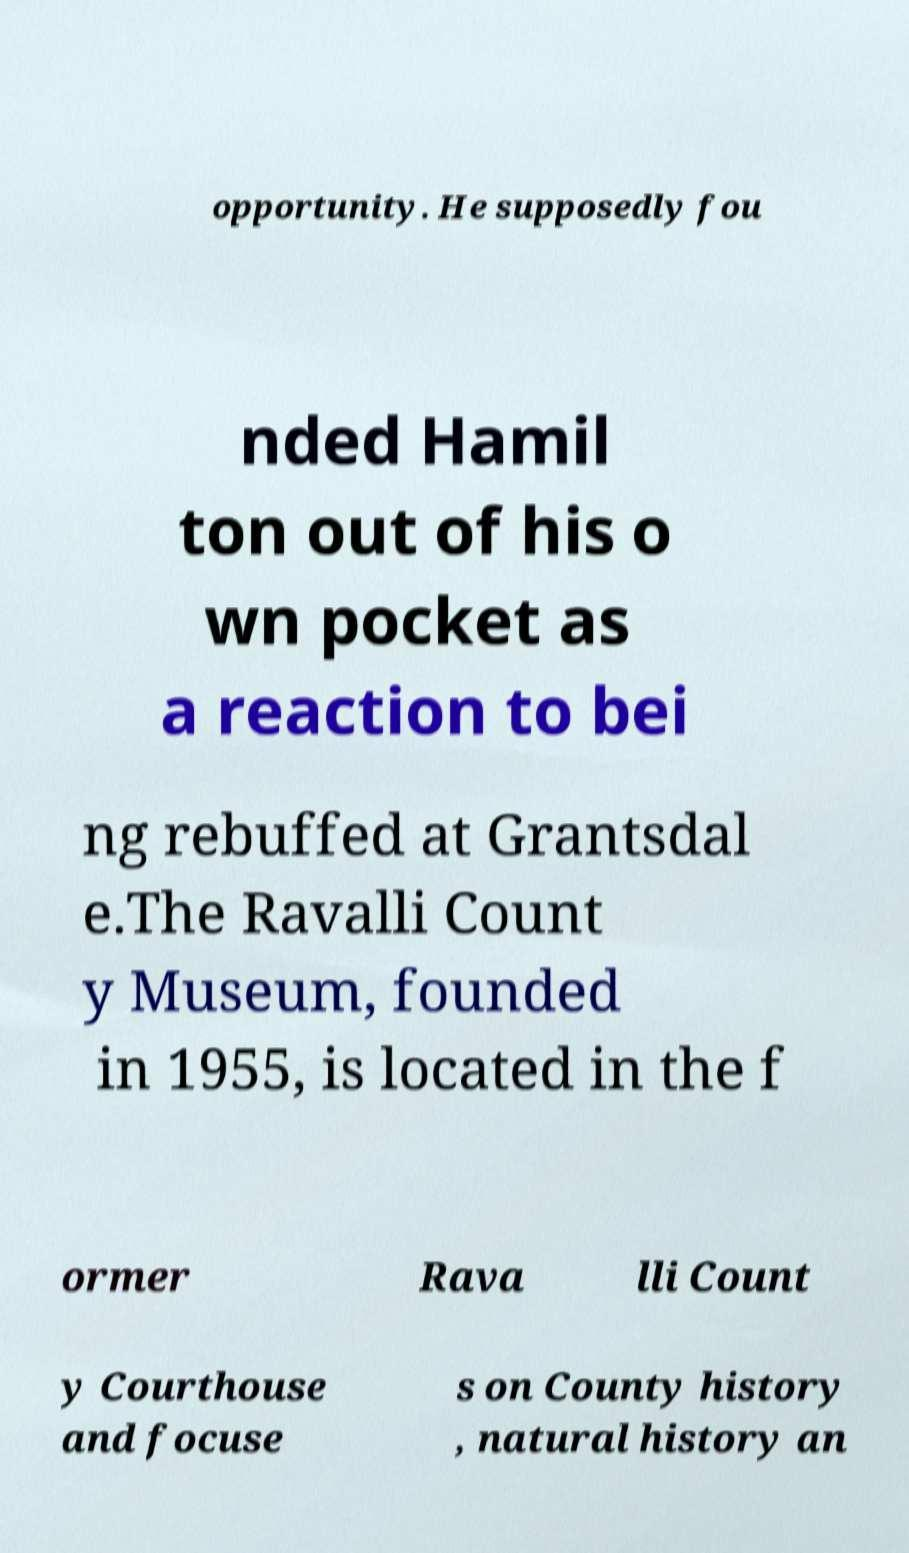What messages or text are displayed in this image? I need them in a readable, typed format. opportunity. He supposedly fou nded Hamil ton out of his o wn pocket as a reaction to bei ng rebuffed at Grantsdal e.The Ravalli Count y Museum, founded in 1955, is located in the f ormer Rava lli Count y Courthouse and focuse s on County history , natural history an 